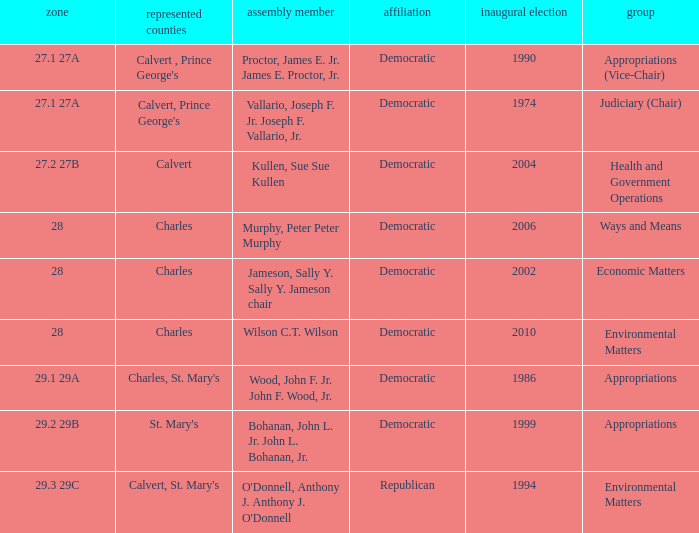Which was the district that had first elected greater than 2006 and is democratic? 28.0. 